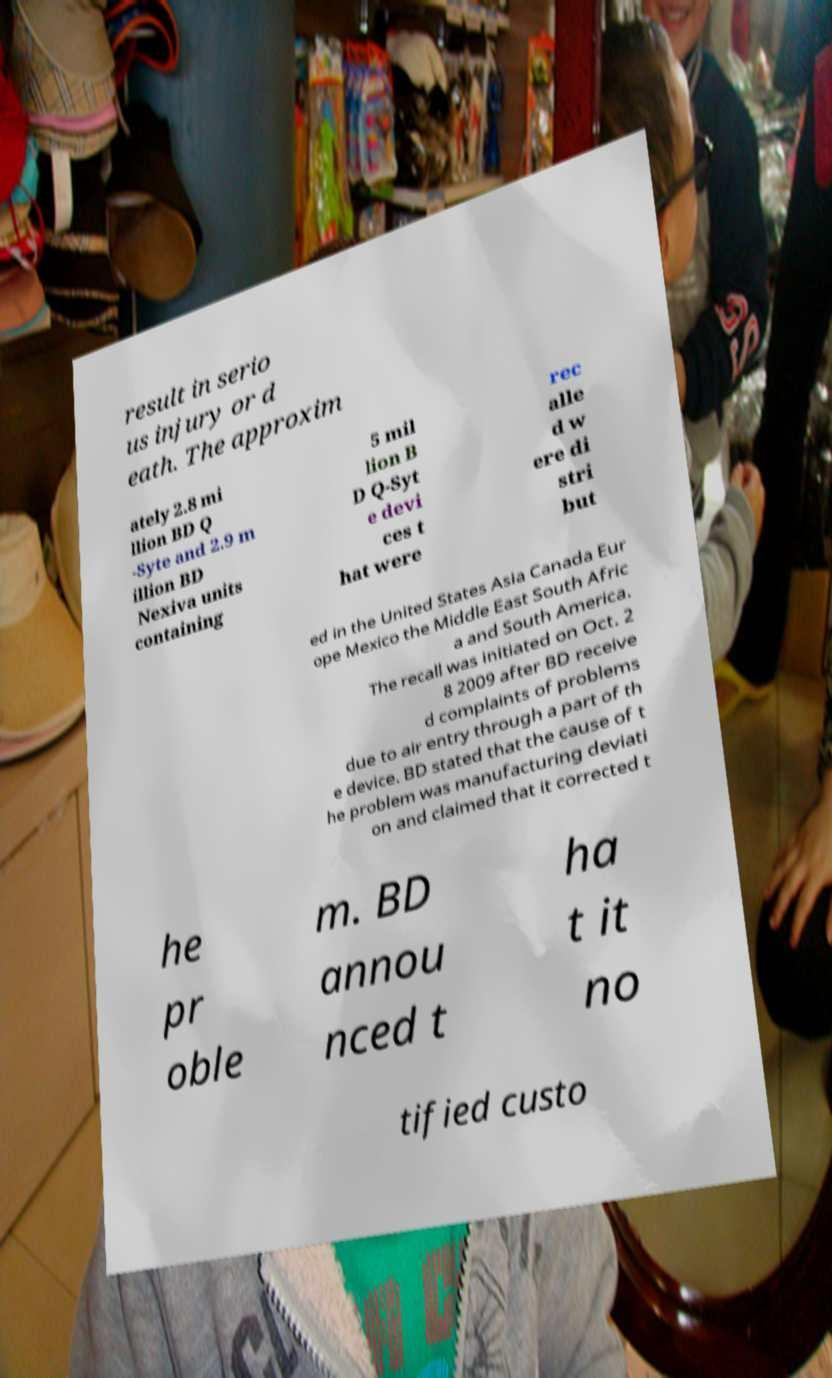What messages or text are displayed in this image? I need them in a readable, typed format. result in serio us injury or d eath. The approxim ately 2.8 mi llion BD Q -Syte and 2.9 m illion BD Nexiva units containing 5 mil lion B D Q-Syt e devi ces t hat were rec alle d w ere di stri but ed in the United States Asia Canada Eur ope Mexico the Middle East South Afric a and South America. The recall was initiated on Oct. 2 8 2009 after BD receive d complaints of problems due to air entry through a part of th e device. BD stated that the cause of t he problem was manufacturing deviati on and claimed that it corrected t he pr oble m. BD annou nced t ha t it no tified custo 